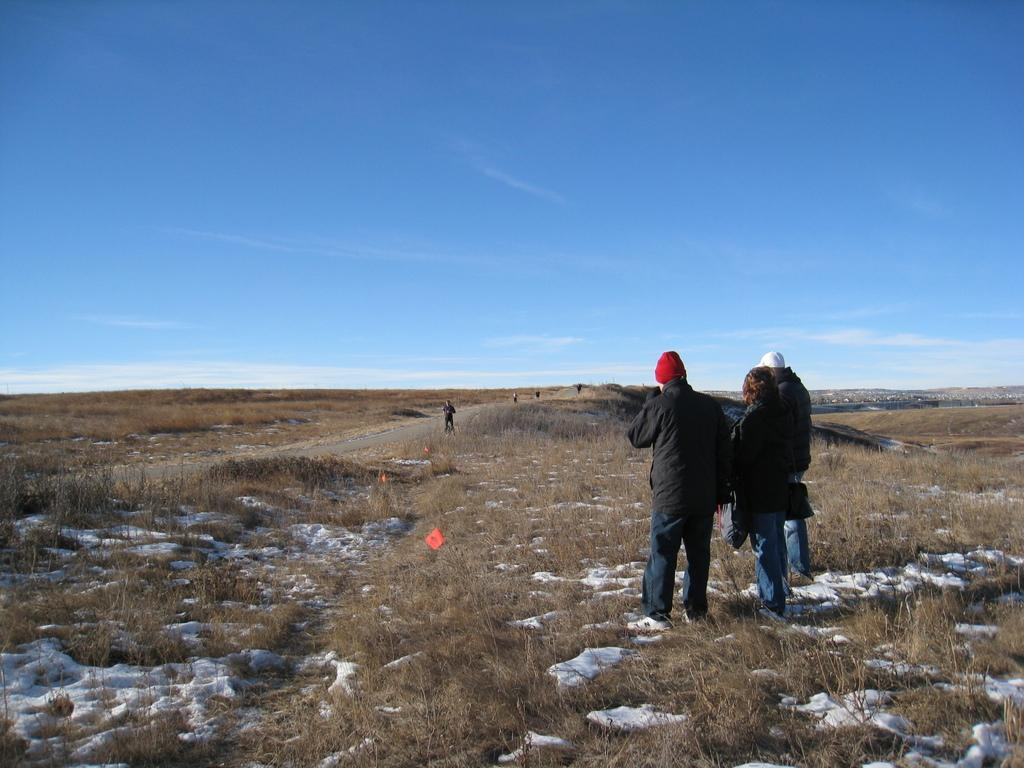What type of terrain is visible in the image? There is ground with dry grass in the image, and there is also snow on the ground. How many people are in the image? There are three people in the image. What are the people wearing? The people are wearing black jackets. What is the position of the people in the image? The people are standing. What is visible in the sky at the top of the image? There is a blue sky visible at the top of the image. What type of downtown area can be seen in the image? There is no downtown area present in the image; it features ground with dry grass, snow, and three people with black jackets. What type of care is being provided to the people in the image? There is no indication in the image that any type of care is being provided to the people; they are simply standing. 